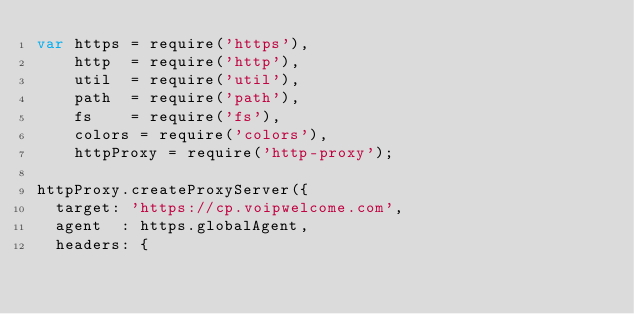<code> <loc_0><loc_0><loc_500><loc_500><_JavaScript_>var https = require('https'),
    http  = require('http'),
    util  = require('util'),
    path  = require('path'),
    fs    = require('fs'),
    colors = require('colors'),
    httpProxy = require('http-proxy');

httpProxy.createProxyServer({
  target: 'https://cp.voipwelcome.com',
  agent  : https.globalAgent,
  headers: {</code> 